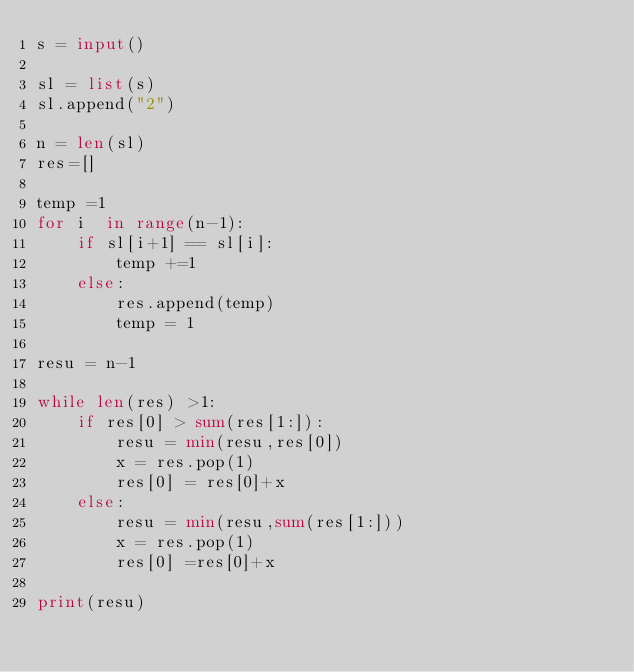Convert code to text. <code><loc_0><loc_0><loc_500><loc_500><_Python_>s = input()

sl = list(s)
sl.append("2")

n = len(sl)
res=[]

temp =1
for i  in range(n-1):
    if sl[i+1] == sl[i]:
        temp +=1
    else:
        res.append(temp)
        temp = 1

resu = n-1

while len(res) >1:
    if res[0] > sum(res[1:]):
        resu = min(resu,res[0])
        x = res.pop(1)
        res[0] = res[0]+x
    else:
        resu = min(resu,sum(res[1:]))
        x = res.pop(1)
        res[0] =res[0]+x

print(resu)</code> 